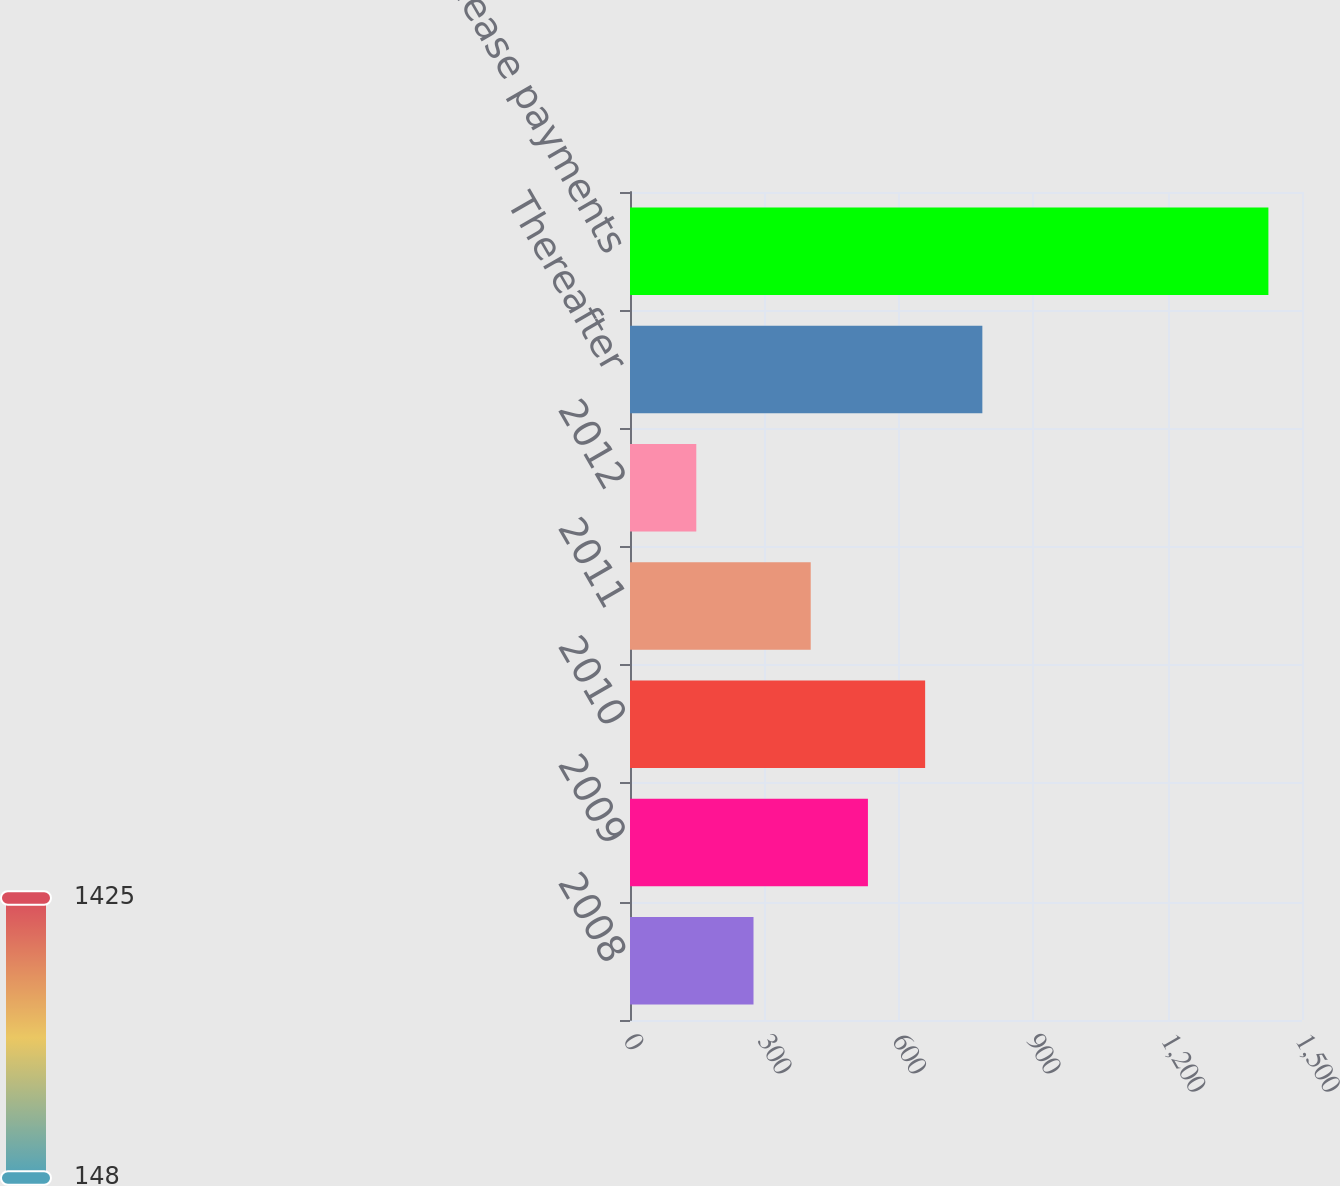Convert chart. <chart><loc_0><loc_0><loc_500><loc_500><bar_chart><fcel>2008<fcel>2009<fcel>2010<fcel>2011<fcel>2012<fcel>Thereafter<fcel>Total minimum lease payments<nl><fcel>275.7<fcel>531.1<fcel>658.8<fcel>403.4<fcel>148<fcel>786.5<fcel>1425<nl></chart> 